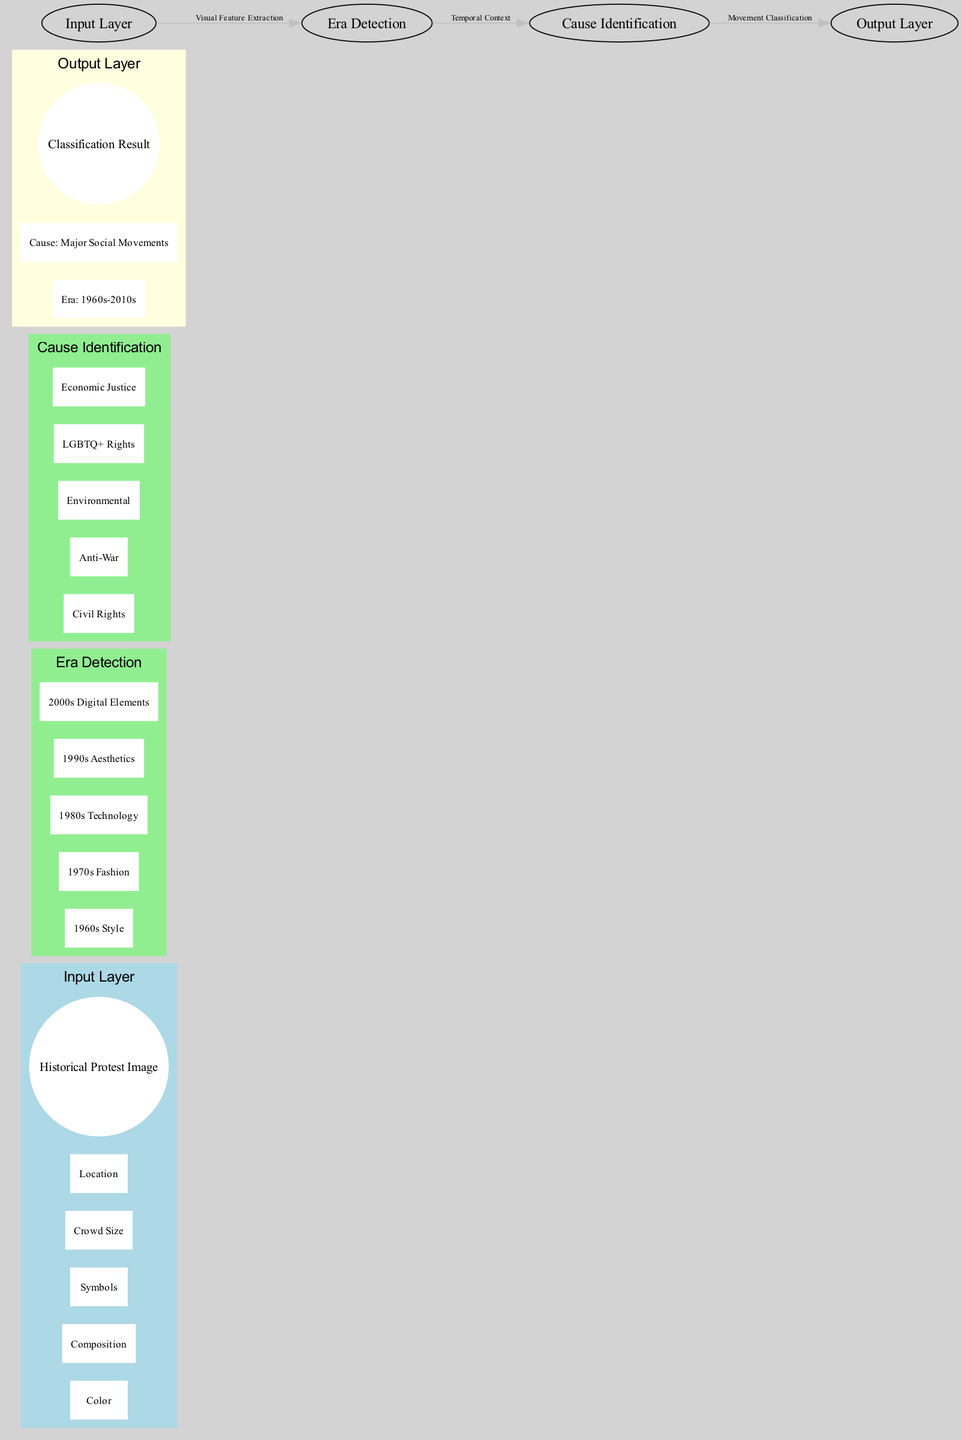What is the name of the output layer? The diagram indicates the name of the output layer is "Classification Result." This can be found within the output layer's labeling section in the diagram.
Answer: Classification Result How many features are in the input layer? The input layer contains five features: Color, Composition, Symbols, Crowd Size, and Location. This count can be derived by counting the listed features under the input layer in the diagram.
Answer: Five What are the nodes in the "Cause Identification" hidden layer? The "Cause Identification" hidden layer contains five nodes: Civil Rights, Anti-War, Environmental, LGBTQ+ Rights, and Economic Justice. By examining the nodes listed under this specific hidden layer, one can gather this information.
Answer: Civil Rights, Anti-War, Environmental, LGBTQ+ Rights, Economic Justice What is the connection label between "Era Detection" and "Cause Identification"? The connection label indicating the relationship between "Era Detection" and "Cause Identification" is "Temporal Context." This can be identified by referencing the connection labeled in the diagram.
Answer: Temporal Context How many nodes are present in total across the hidden layers? There are a total of ten nodes, consisting of five nodes from the "Era Detection" layer and five nodes from the "Cause Identification" layer. Summing the nodes from both hidden layers leads to this total.
Answer: Ten What directs visual feature extraction in this diagram? "Visual Feature Extraction" directs the flow from the "Input Layer" to the "Era Detection" layer. This labeling in the diagram explicitly indicates what process is occurring at this connection.
Answer: Visual Feature Extraction What is labeled under the input layer? The input layer is labeled with "Historical Protest Image." This is the overarching label for the input section, clearly specified in the diagram.
Answer: Historical Protest Image What are the categories in the output layer? The categories in the output layer are "Era: 1960s-2010s" and "Cause: Major Social Movements." This can be found in the output layer's category section as delineated in the diagram.
Answer: Era: 1960s-2010s, Cause: Major Social Movements What is the purpose of the "Era Detection" hidden layer? The purpose of the "Era Detection" hidden layer is to categorize images based on styles related to different decades from the 1960s to the 2000s. This can be understood by examining the nodes it comprises, which focus on specific visual characteristics from those time periods.
Answer: Categorize images by styles 